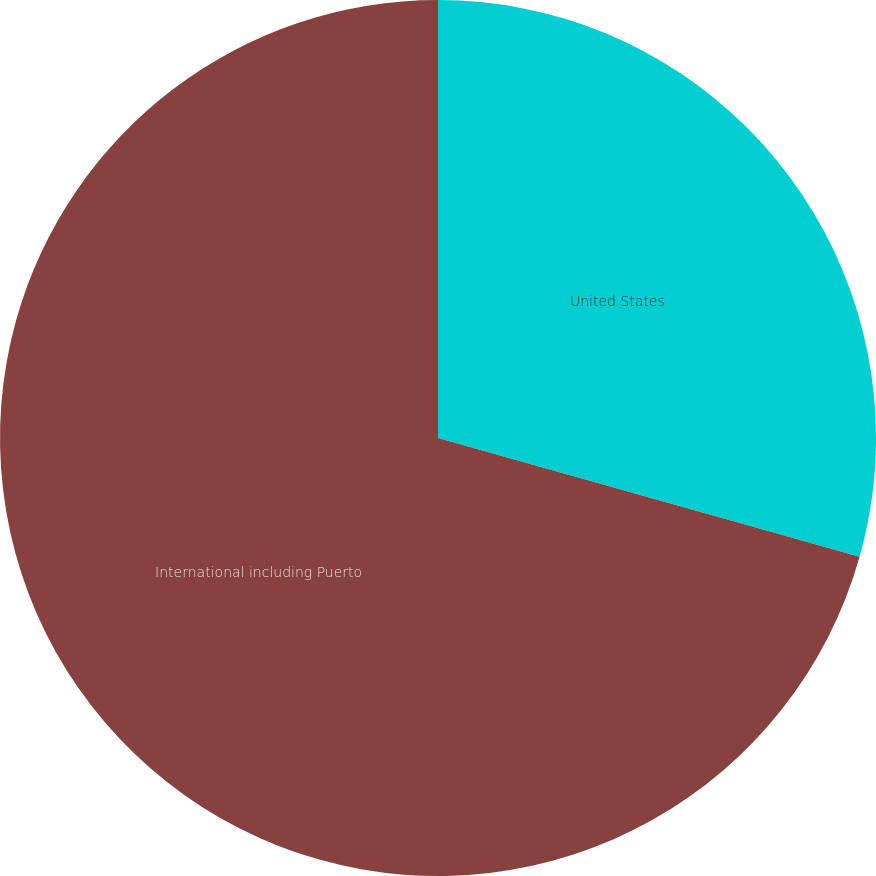Convert chart. <chart><loc_0><loc_0><loc_500><loc_500><pie_chart><fcel>United States<fcel>International including Puerto<nl><fcel>29.37%<fcel>70.63%<nl></chart> 